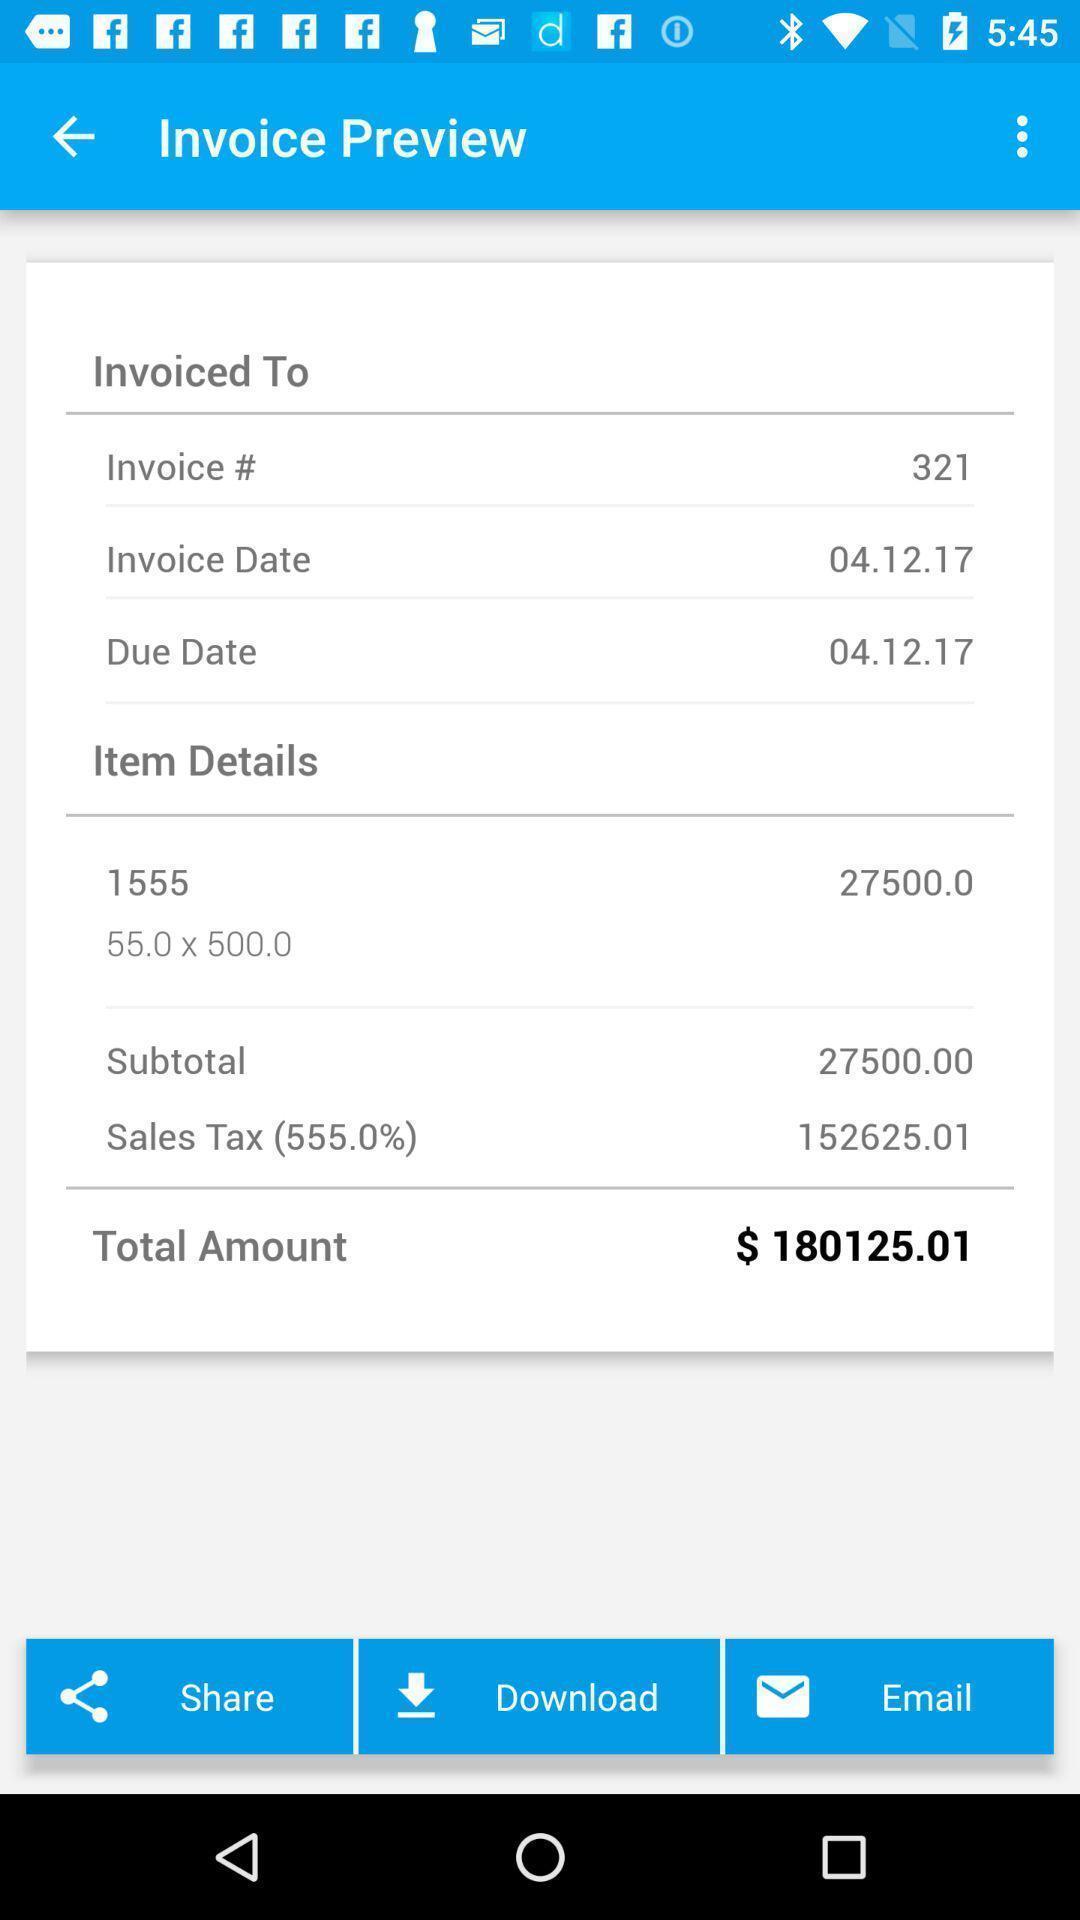Describe the key features of this screenshot. Page with different input details to create an invoice. 